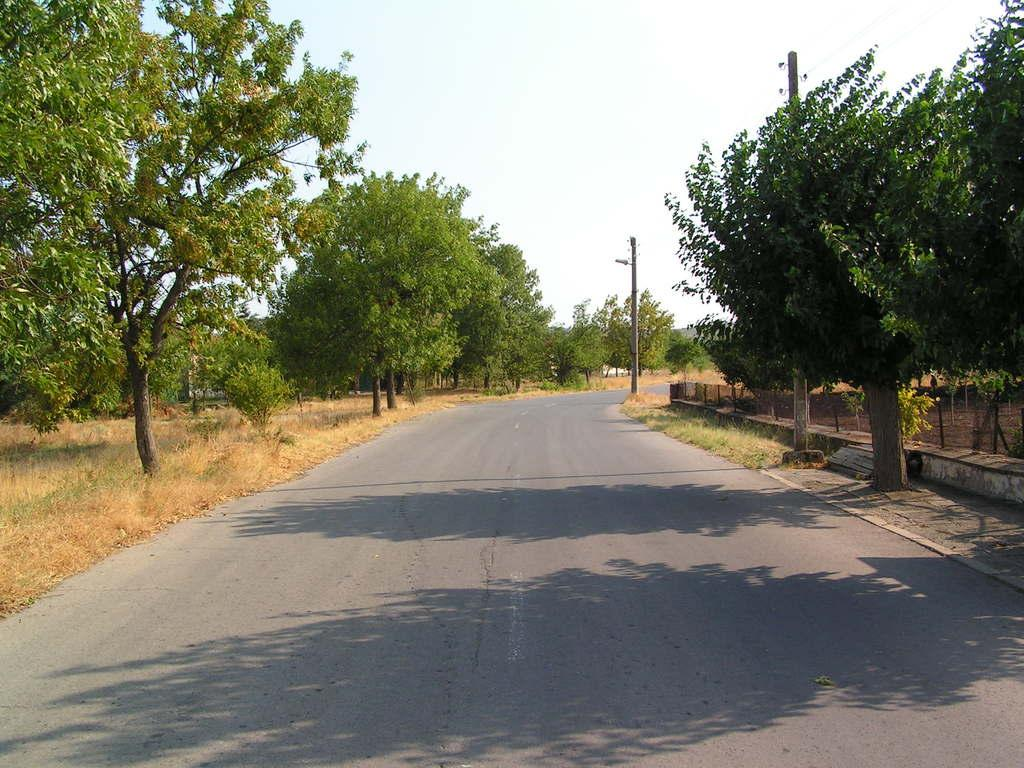What is the main feature of the image? There is a road in the image. How is the road positioned in relation to the trees? The road is situated between trees. What else can be seen beside the road? There are poles beside the road. What is visible at the top of the image? The sky is visible at the top of the image. What type of seat can be seen in the image? There is no seat present in the image. What things are happening in the image? The image does not depict any actions or events, it only shows a road, trees, poles, and the sky. 